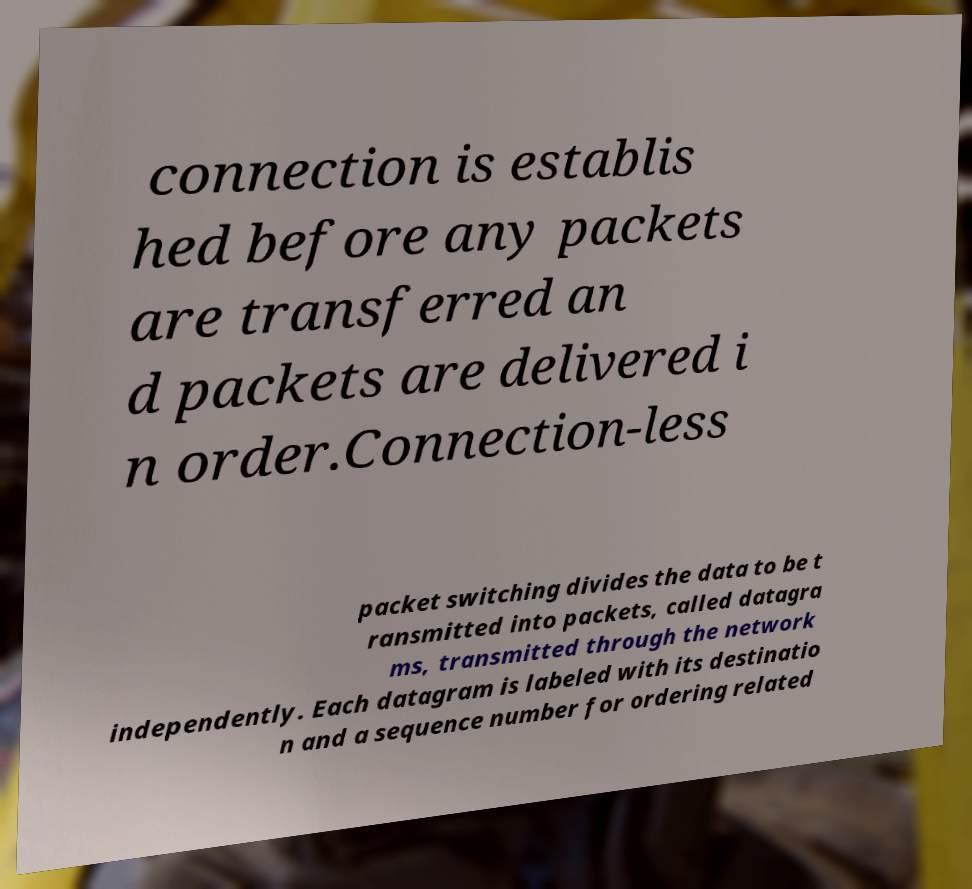Could you extract and type out the text from this image? connection is establis hed before any packets are transferred an d packets are delivered i n order.Connection-less packet switching divides the data to be t ransmitted into packets, called datagra ms, transmitted through the network independently. Each datagram is labeled with its destinatio n and a sequence number for ordering related 